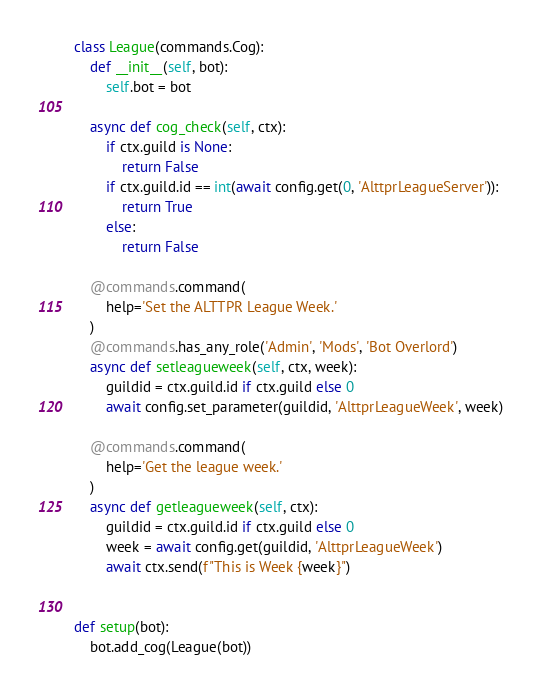Convert code to text. <code><loc_0><loc_0><loc_500><loc_500><_Python_>

class League(commands.Cog):
    def __init__(self, bot):
        self.bot = bot

    async def cog_check(self, ctx):
        if ctx.guild is None:
            return False
        if ctx.guild.id == int(await config.get(0, 'AlttprLeagueServer')):
            return True
        else:
            return False

    @commands.command(
        help='Set the ALTTPR League Week.'
    )
    @commands.has_any_role('Admin', 'Mods', 'Bot Overlord')
    async def setleagueweek(self, ctx, week):
        guildid = ctx.guild.id if ctx.guild else 0
        await config.set_parameter(guildid, 'AlttprLeagueWeek', week)

    @commands.command(
        help='Get the league week.'
    )
    async def getleagueweek(self, ctx):
        guildid = ctx.guild.id if ctx.guild else 0
        week = await config.get(guildid, 'AlttprLeagueWeek')
        await ctx.send(f"This is Week {week}")


def setup(bot):
    bot.add_cog(League(bot))
</code> 